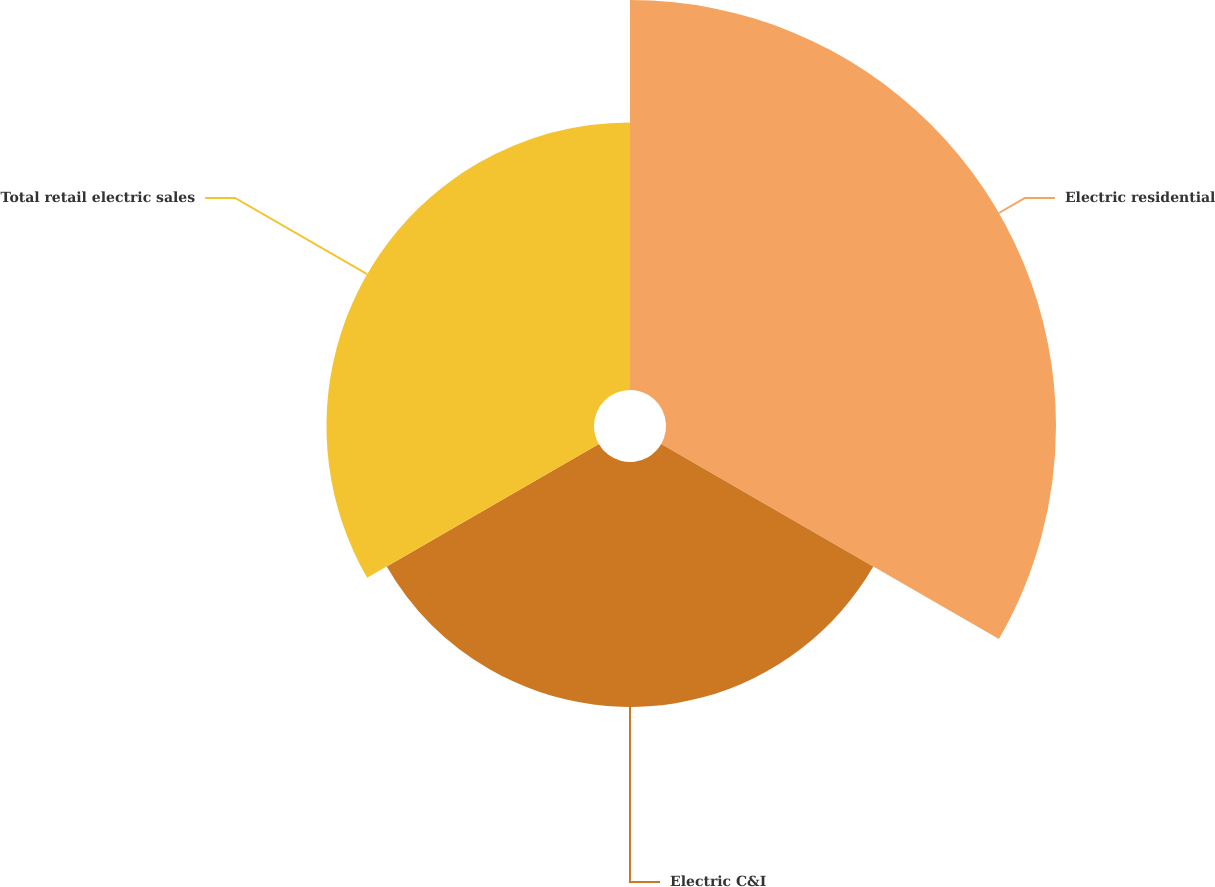<chart> <loc_0><loc_0><loc_500><loc_500><pie_chart><fcel>Electric residential<fcel>Electric C&I<fcel>Total retail electric sales<nl><fcel>43.22%<fcel>27.14%<fcel>29.65%<nl></chart> 